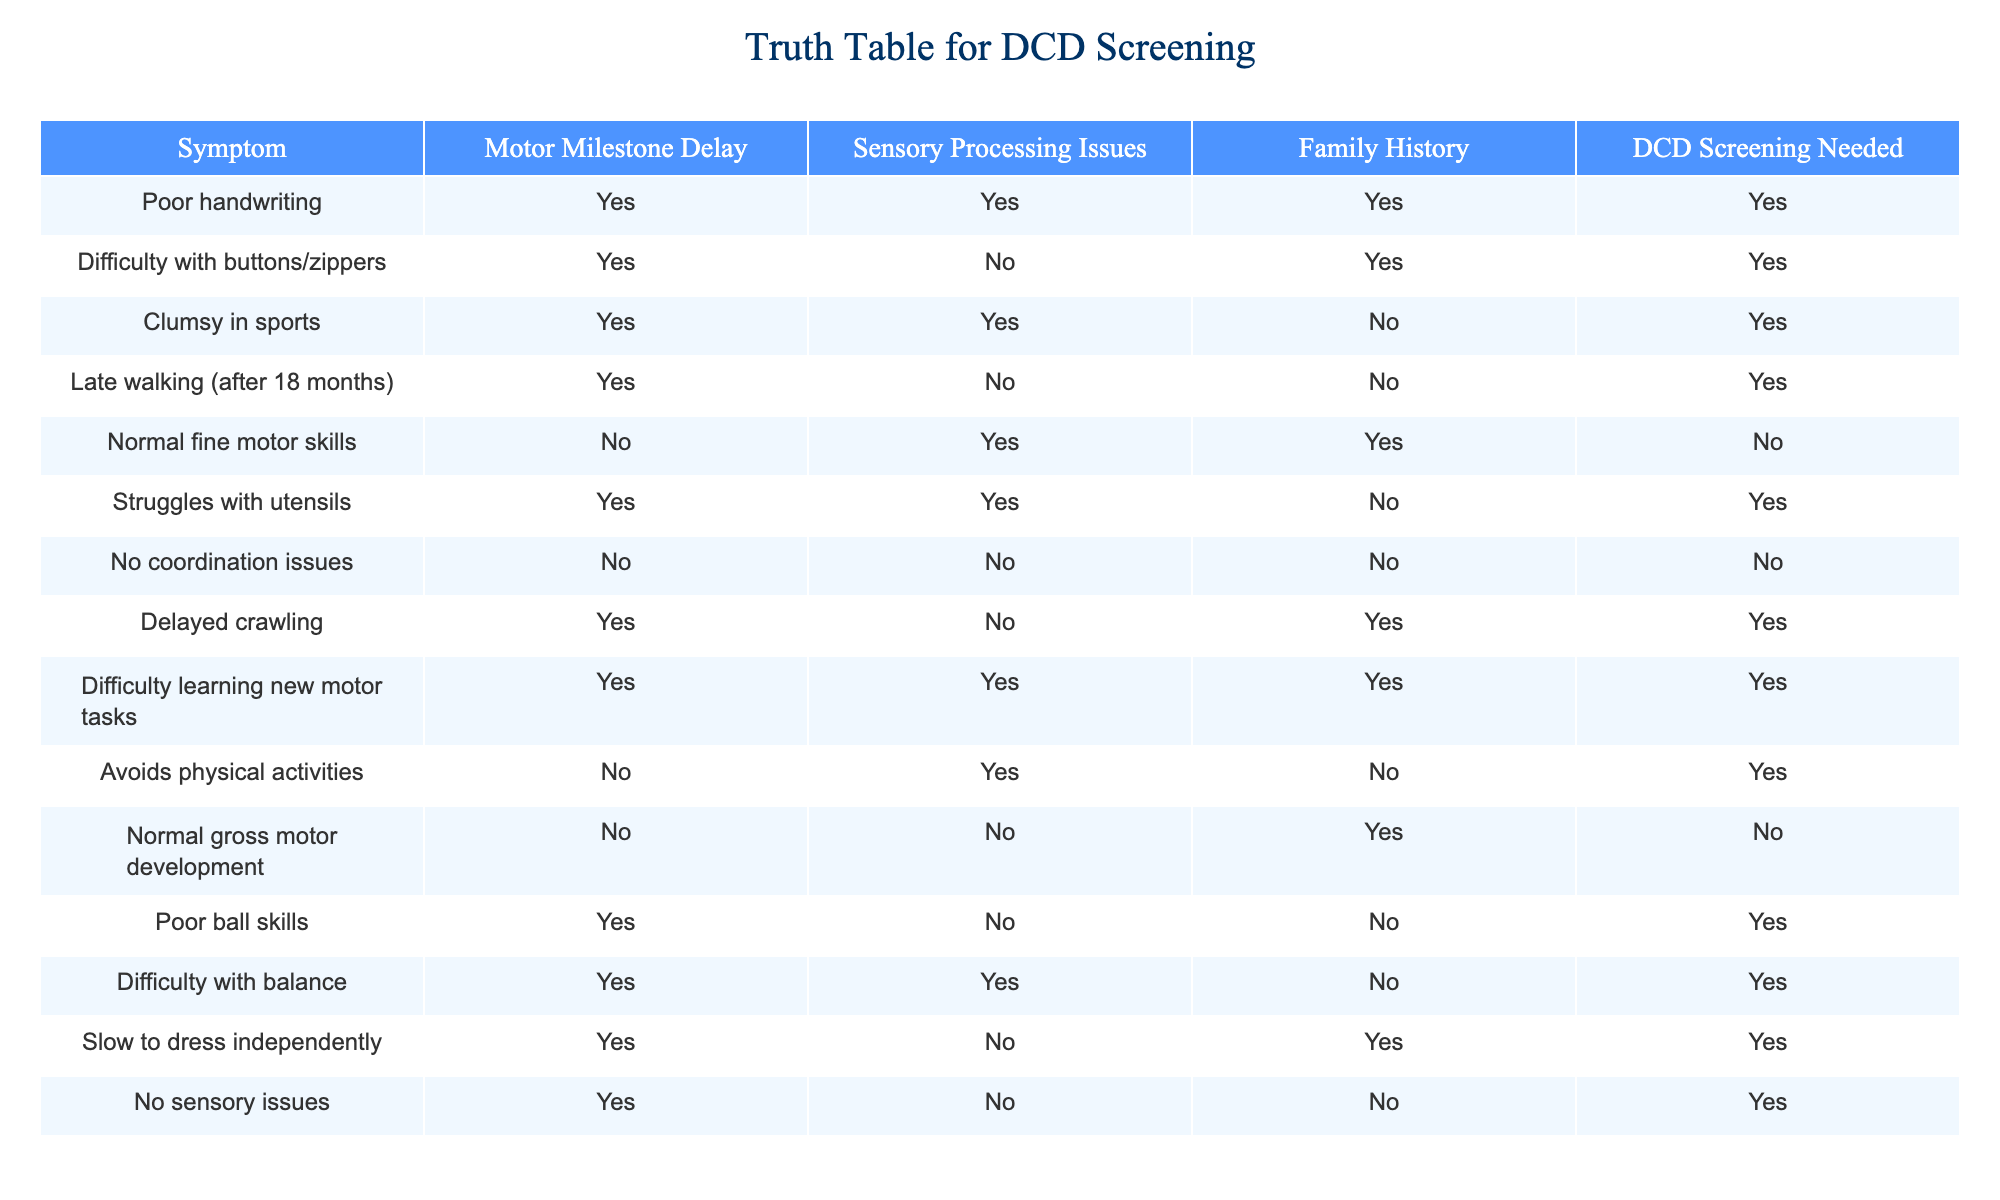What symptoms require DCD screening? The table indicates that symptoms such as poor handwriting, difficulty with buttons/zippers, clumsy in sports, late walking after 18 months, struggles with utensils, difficulty learning new motor tasks, poor ball skills, difficulty with balance, slow to dress independently, and delayed crawling all correspond with "DCD Screening Needed" labeled as TRUE.
Answer: Poor handwriting, difficulty with buttons/zippers, clumsy in sports, late walking after 18 months, struggles with utensils, difficulty learning new motor tasks, poor ball skills, difficulty with balance, slow to dress independently, delayed crawling How many symptoms are associated with sensory processing issues and DCD screening is needed? From the table, the symptoms that have sensory processing issues (TRUE) and also require DCD screening (TRUE) are poor handwriting, difficulty learning new motor tasks, clumsy in sports, and difficulty with balance. This makes a total of 4 symptoms.
Answer: 4 Is there any symptom with normal fine motor skills that requires DCD screening? The table indicates that "Normal fine motor skills" is listed as FALSE under the need for DCD screening, meaning it does not require DCD screening. Therefore, there are no symptoms with normal fine motor skills that require DCD screening.
Answer: No What is the total number of symptoms indicating a family history associated with DCD screening needed? By checking the table, the symptoms requiring DCD screening that also have a family history marked as TRUE are poor handwriting, difficulty with buttons/zippers, delayed crawling, difficulty learning new motor tasks, and slow to dress independently. This gives a total of 5 symptoms.
Answer: 5 Are there any symptoms where sensory processing issues are absent, but DCD screening is required? The symptoms of late walking after 18 months, poor ball skills, and difficulty with balance are where sensory processing issues are marked as FALSE but still require DCD screening (marked as TRUE). This indicates there are such symptoms present.
Answer: Yes What percentage of symptoms signify both motor milestone delay and require DCD screening? There are 8 symptoms that indicate a motor milestone delay marked as TRUE. Out of these, all 8 also require DCD screening, which gives us 100%. The percentage is calculated as (8/8) * 100 = 100%.
Answer: 100% Which symptom with no coordination issues is marked for DCD screening? According to the table, the symptom "No coordination issues" has DCD screening needed marked as FALSE. Therefore, none of the symptoms with no coordination issues require DCD screening.
Answer: None Are all symptoms with clumsiness related to DCD screening needed? The symptoms related to clumsiness in the table, specifically "clumsy in sports" and "difficulty with balance," both indicate that DCD screening is needed. However, clumsiness is not universal as indicated by the category "No coordination issues." Therefore, while many clumsy symptoms are associated with DCD screening, not all are.
Answer: No 